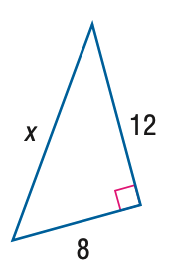Answer the mathemtical geometry problem and directly provide the correct option letter.
Question: Find x.
Choices: A: 4 \sqrt { 5 } B: 4 \sqrt { 13 } C: 8 \sqrt { 5 } D: 8 \sqrt { 13 } B 